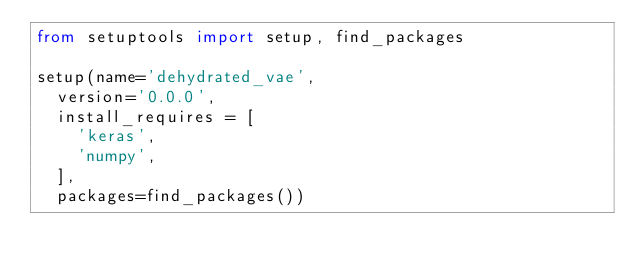<code> <loc_0><loc_0><loc_500><loc_500><_Python_>from setuptools import setup, find_packages

setup(name='dehydrated_vae',
  version='0.0.0',
  install_requires = [
    'keras',
    'numpy',
  ],
  packages=find_packages())
</code> 